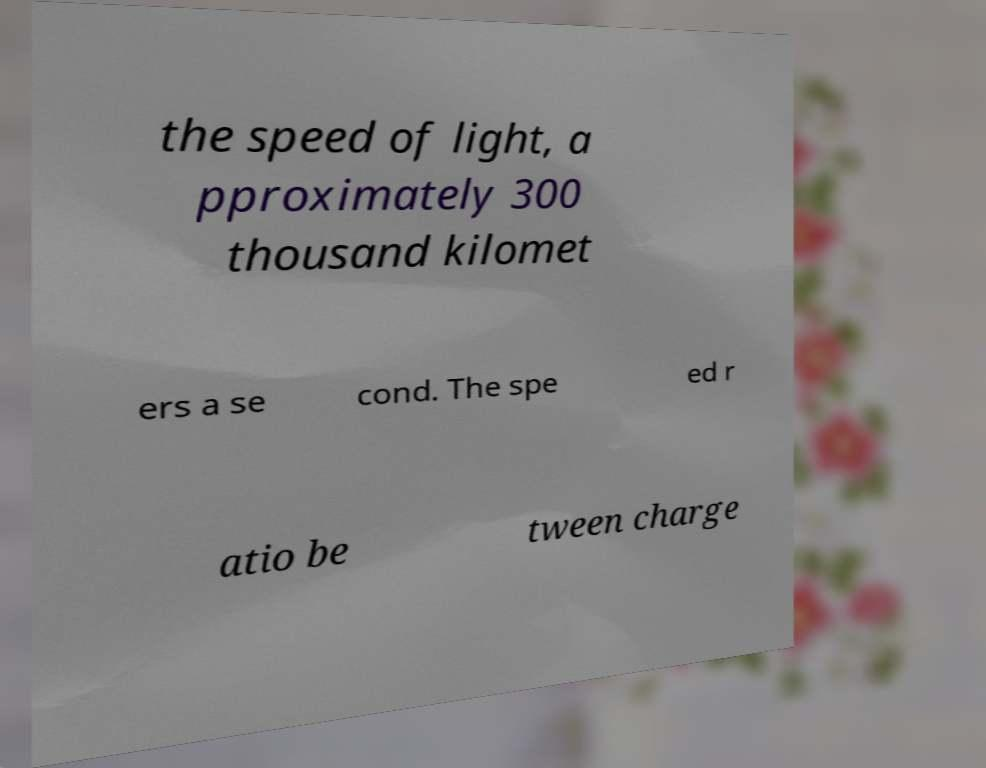Please read and relay the text visible in this image. What does it say? the speed of light, a pproximately 300 thousand kilomet ers a se cond. The spe ed r atio be tween charge 